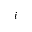Convert formula to latex. <formula><loc_0><loc_0><loc_500><loc_500>i</formula> 